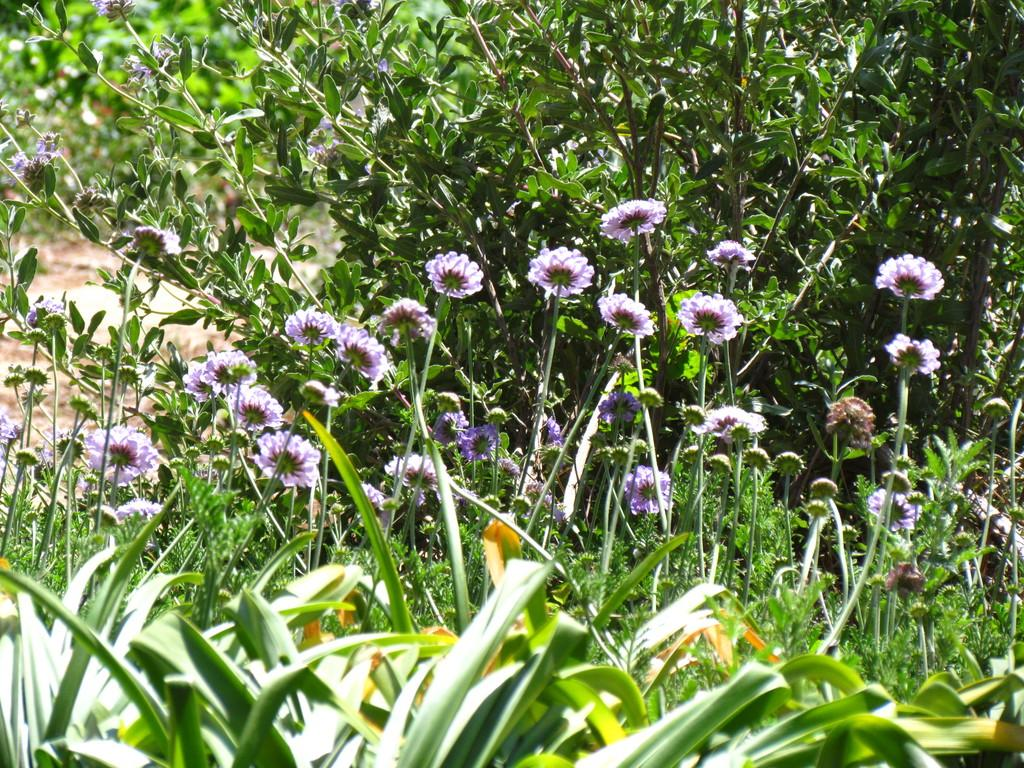What type of living organisms can be seen in the image? Flowers and plants are visible in the image. What is the surface on which the flowers and plants are situated? The ground is visible in the image. Can you tell me how many frogs are sitting on the flowers in the image? There are no frogs present in the image; it only features flowers and plants. 